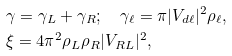<formula> <loc_0><loc_0><loc_500><loc_500>& \gamma = \gamma _ { L } + \gamma _ { R } ; \quad \gamma _ { \ell } = \pi | V _ { d \ell } | ^ { 2 } \rho _ { \ell } , \\ & \xi = 4 \pi ^ { 2 } \rho _ { L } \rho _ { R } | V _ { R L } | ^ { 2 } ,</formula> 